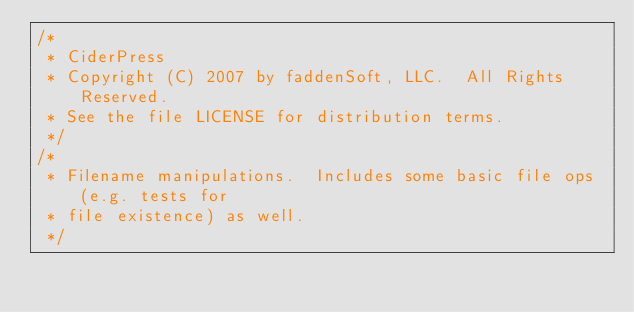Convert code to text. <code><loc_0><loc_0><loc_500><loc_500><_C_>/*
 * CiderPress
 * Copyright (C) 2007 by faddenSoft, LLC.  All Rights Reserved.
 * See the file LICENSE for distribution terms.
 */
/*
 * Filename manipulations.  Includes some basic file ops (e.g. tests for
 * file existence) as well.
 */</code> 